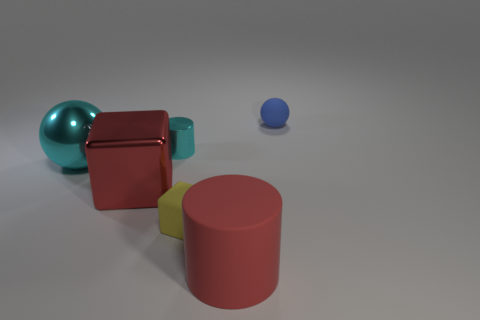If this were a physical model for a product design, what considerations might a designer have made? If this were a model for product design, the designer might be showcasing an understanding of form, color, and material. Each shape's proportion, spacing, and surface texture would be carefully considered for aesthetic appeal or functional purpose. The muted background accentuates the shapes, suggesting that the designer has focused on simplicity and clarity to highlight the product's features. What kind of product could these shapes be a model for? These shapes could be a conceptual model for a variety of products ranging from children's toys to decorative home accessories or even part of a branding exercise. The playful nature of the geometric shapes could lend themselves well to educational toys that teach about shapes and colors, whereas the minimalist design could appeal to a modern home decor line. 